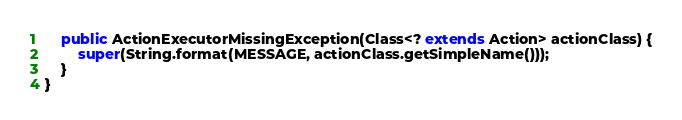<code> <loc_0><loc_0><loc_500><loc_500><_Java_>
    public ActionExecutorMissingException(Class<? extends Action> actionClass) {
        super(String.format(MESSAGE, actionClass.getSimpleName()));
    }
}
</code> 